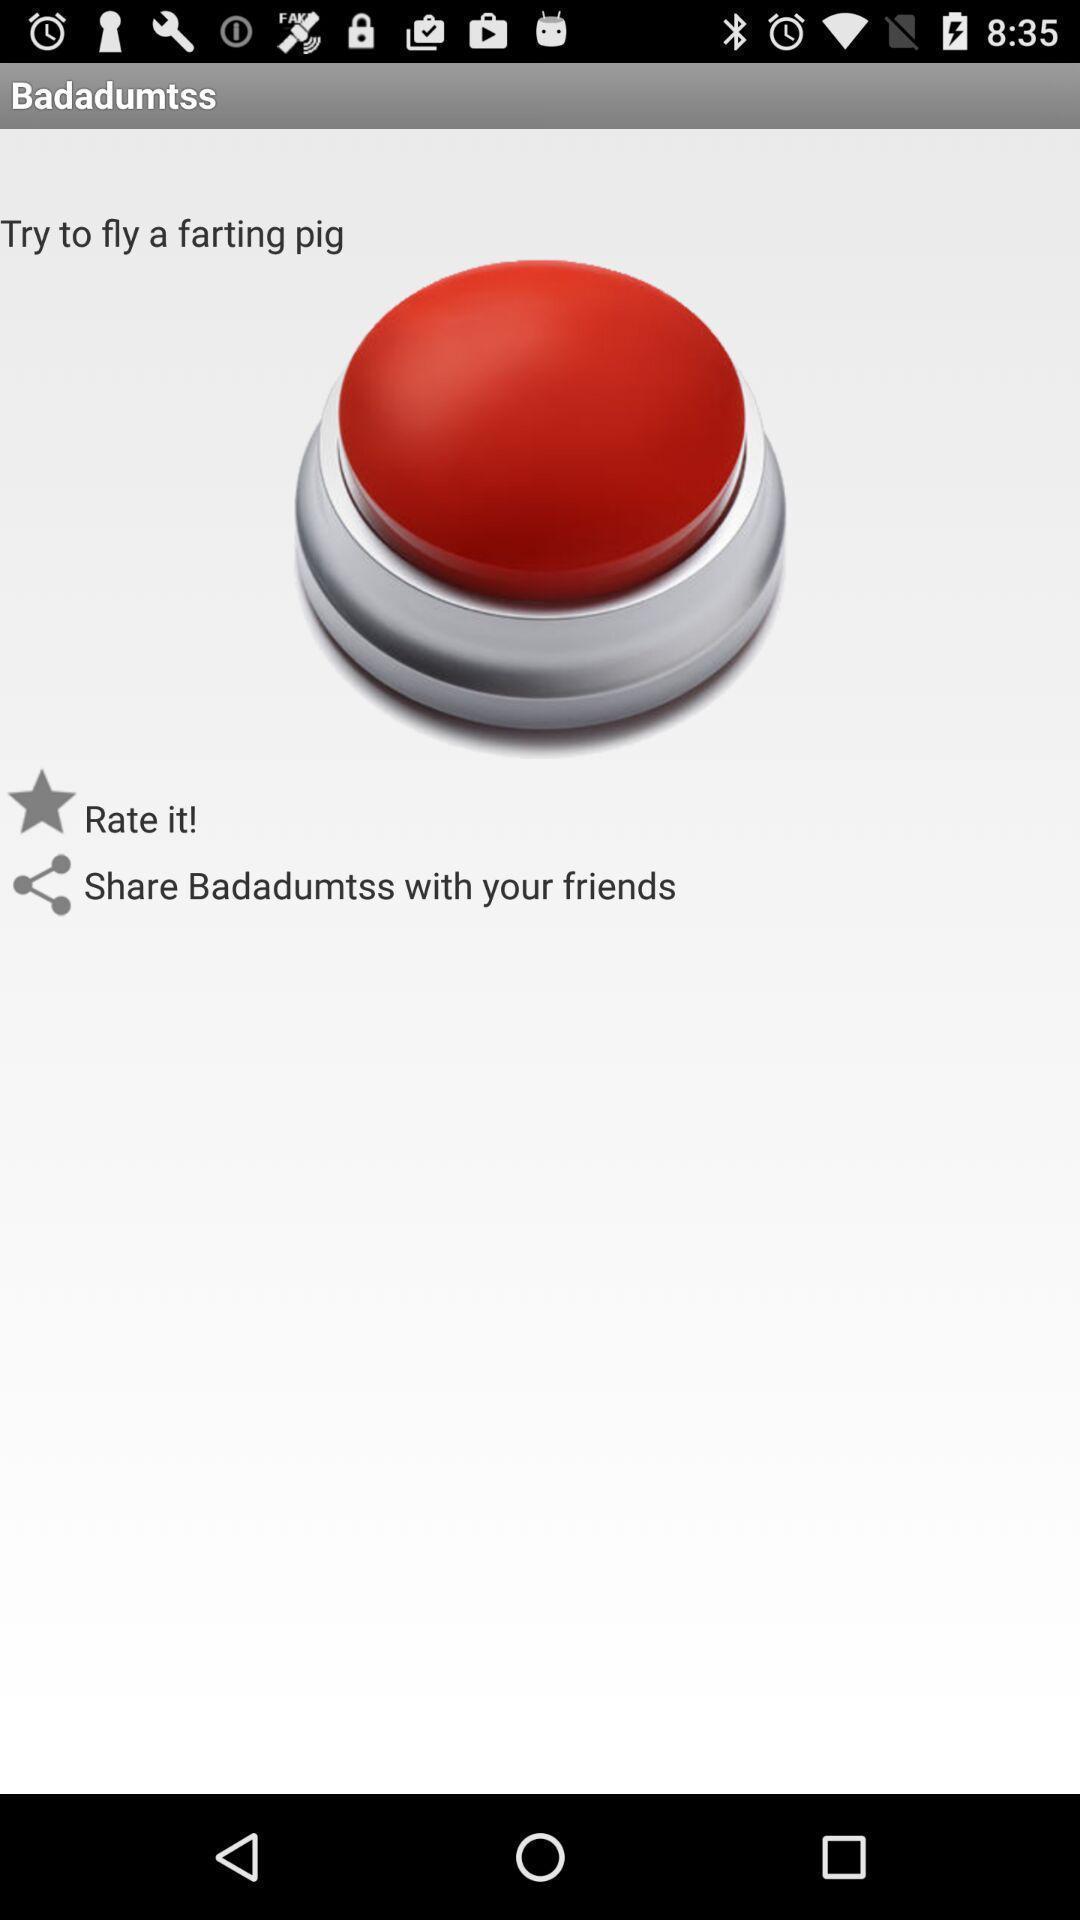Provide a description of this screenshot. Page showing rate it and share options. 